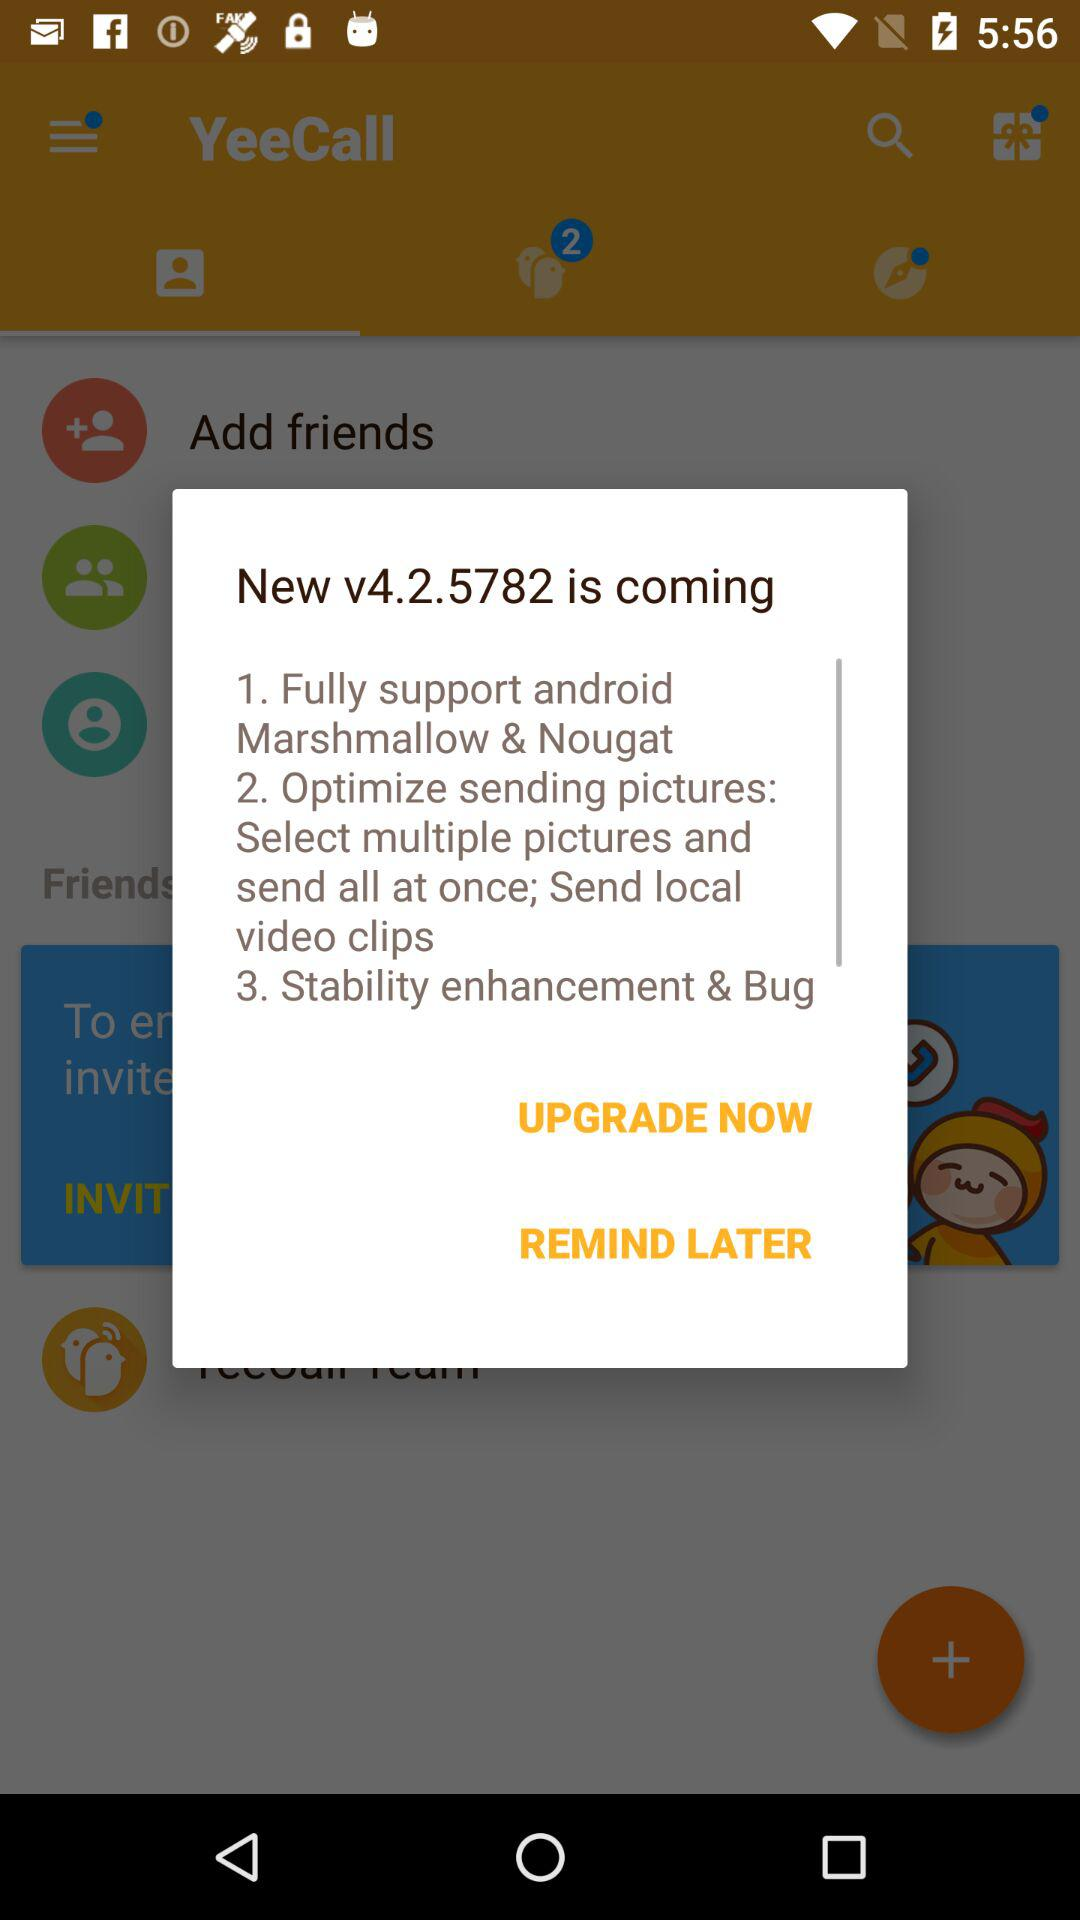What is the latest version? The latest version is v4.2.5782. 